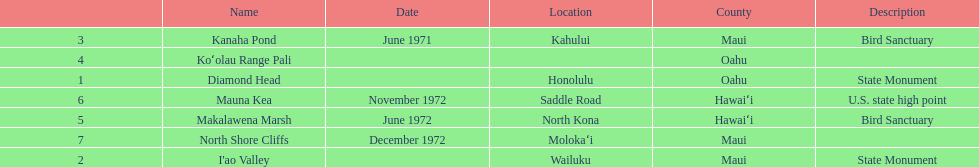Which county is featured the most on the chart? Maui. 